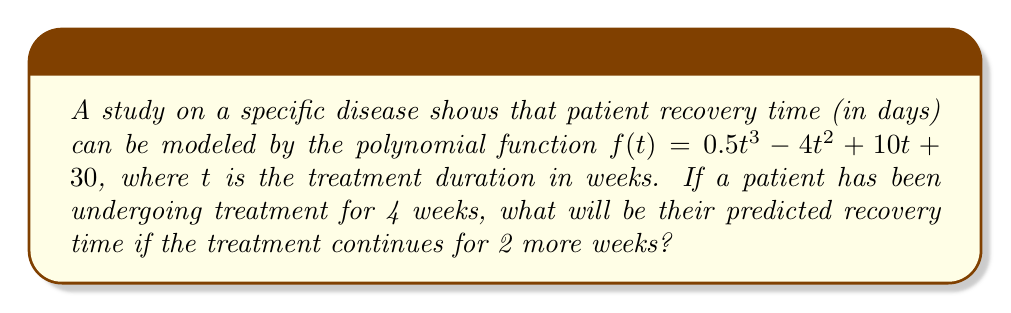Can you solve this math problem? To solve this problem, we'll follow these steps:

1) We're given the polynomial function: $f(t) = 0.5t^3 - 4t^2 + 10t + 30$

2) We need to calculate the difference between $f(6)$ and $f(4)$, as the patient has been treated for 4 weeks and will continue for 2 more weeks (total 6 weeks).

3) Let's calculate $f(6)$:
   $f(6) = 0.5(6^3) - 4(6^2) + 10(6) + 30$
   $= 0.5(216) - 4(36) + 60 + 30$
   $= 108 - 144 + 60 + 30$
   $= 54$ days

4) Now let's calculate $f(4)$:
   $f(4) = 0.5(4^3) - 4(4^2) + 10(4) + 30$
   $= 0.5(64) - 4(16) + 40 + 30$
   $= 32 - 64 + 40 + 30$
   $= 38$ days

5) The difference in recovery time is:
   $f(6) - f(4) = 54 - 38 = 16$ days

Therefore, the patient's predicted recovery time will increase by 16 days if the treatment continues for 2 more weeks.
Answer: 16 days 